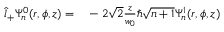<formula> <loc_0><loc_0><loc_500><loc_500>\begin{array} { r l } { \hat { l } _ { + } \Psi _ { n } ^ { 0 } ( r , \phi , z ) = } & - 2 \sqrt { 2 } \frac { z } { w _ { 0 } } \hbar { \sqrt } { n + 1 } \Psi _ { n } ^ { 1 } ( r , \phi , z ) } \end{array}</formula> 